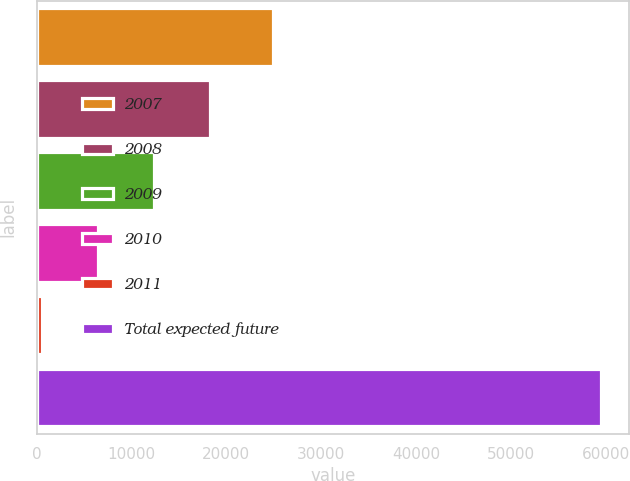Convert chart. <chart><loc_0><loc_0><loc_500><loc_500><bar_chart><fcel>2007<fcel>2008<fcel>2009<fcel>2010<fcel>2011<fcel>Total expected future<nl><fcel>24906<fcel>18233.6<fcel>12335.4<fcel>6437.2<fcel>539<fcel>59521<nl></chart> 